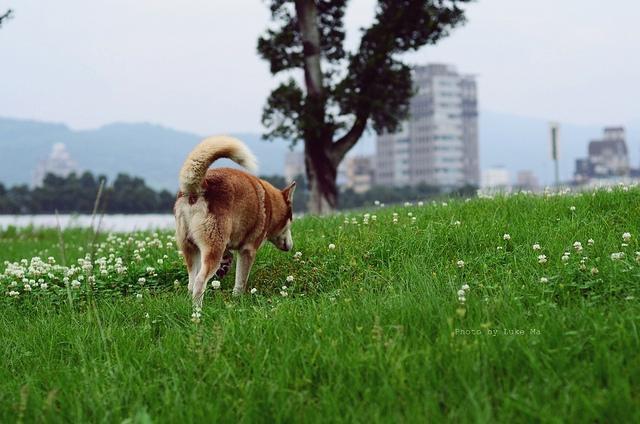How many dogs can you see?
Give a very brief answer. 1. How many people are looking at the camera in this picture?
Give a very brief answer. 0. 